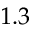<formula> <loc_0><loc_0><loc_500><loc_500>1 . 3</formula> 